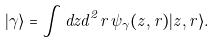Convert formula to latex. <formula><loc_0><loc_0><loc_500><loc_500>| \gamma \rangle = \int d z d ^ { 2 } r \, \psi _ { \gamma } ( z , r ) | z , r \rangle .</formula> 